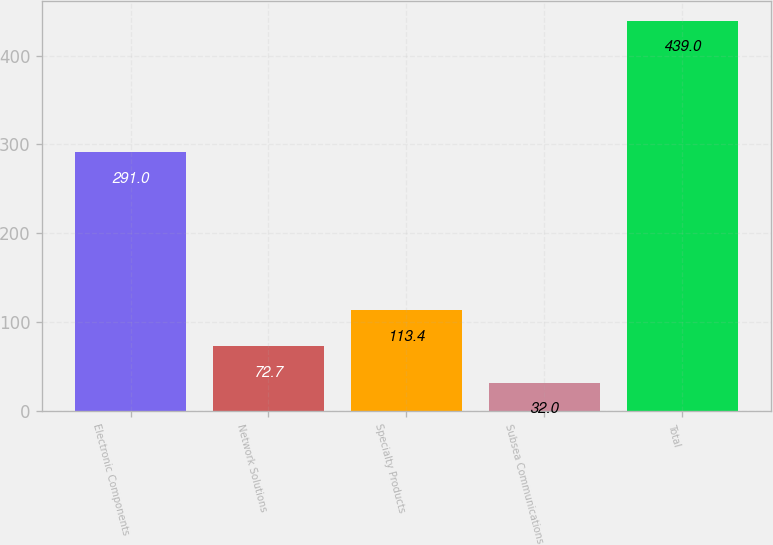Convert chart to OTSL. <chart><loc_0><loc_0><loc_500><loc_500><bar_chart><fcel>Electronic Components<fcel>Network Solutions<fcel>Specialty Products<fcel>Subsea Communications<fcel>Total<nl><fcel>291<fcel>72.7<fcel>113.4<fcel>32<fcel>439<nl></chart> 